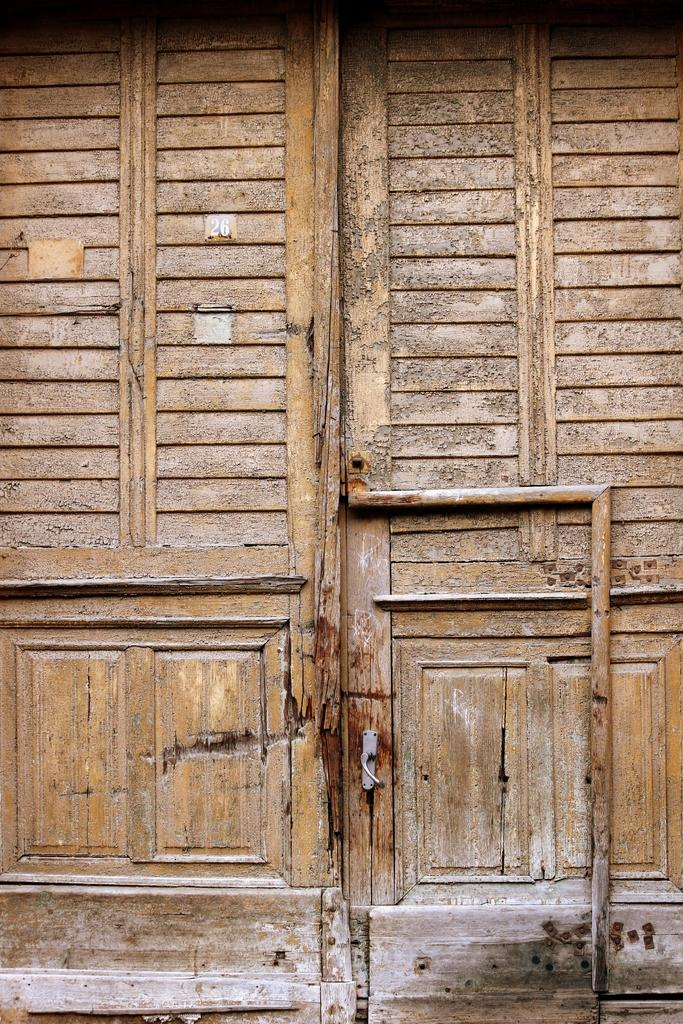What type of material is used for the wall in the foreground of the image? The wall in the foreground of the image is made of wood. Can you describe any specific features of the wooden wall? Yes, there is a handle associated with the wooden wall. What type of hill can be seen in the background of the image? There is no hill visible in the image; it only features a wooden wall with a handle. 